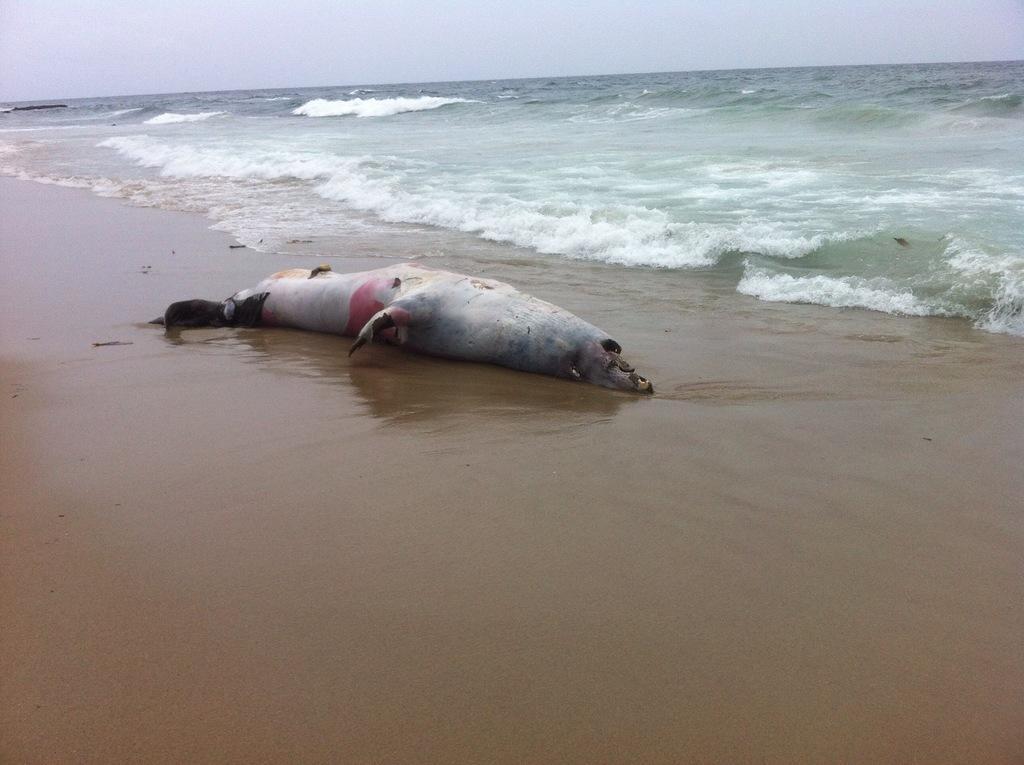How would you summarize this image in a sentence or two? In this picture It looks like a seal on the shore and I can see water and a cloudy sky. 